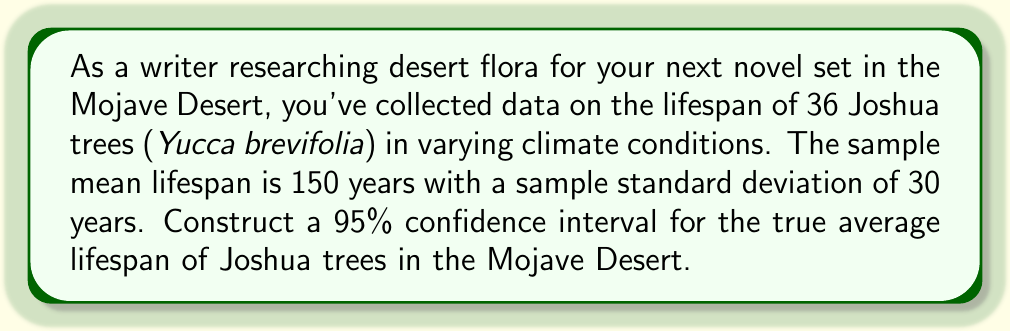Can you answer this question? To construct a 95% confidence interval for the true average lifespan of Joshua trees, we'll follow these steps:

1. Identify the given information:
   - Sample size: $n = 36$
   - Sample mean: $\bar{x} = 150$ years
   - Sample standard deviation: $s = 30$ years
   - Confidence level: 95% (α = 0.05)

2. Determine the critical value:
   For a 95% confidence interval with 35 degrees of freedom (n-1), we use the t-distribution. The critical value is $t_{0.025,35} = 2.030$.

3. Calculate the standard error of the mean:
   $SE = \frac{s}{\sqrt{n}} = \frac{30}{\sqrt{36}} = 5$

4. Compute the margin of error:
   $ME = t_{0.025,35} \times SE = 2.030 \times 5 = 10.15$

5. Construct the confidence interval:
   $CI = \bar{x} \pm ME$
   $CI = 150 \pm 10.15$
   $CI = (139.85, 160.15)$

Therefore, we can be 95% confident that the true average lifespan of Joshua trees in the Mojave Desert is between 139.85 and 160.15 years.
Answer: (139.85, 160.15) years 